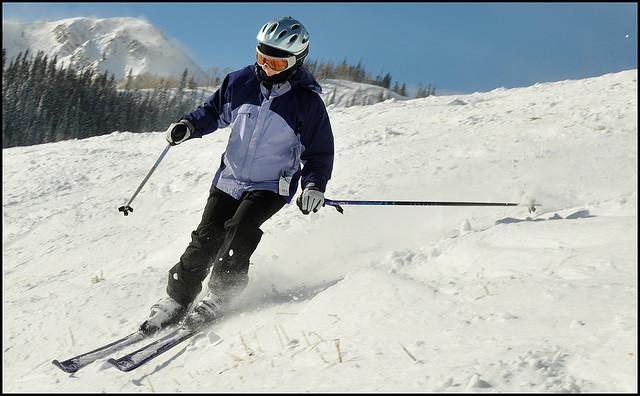What do you call the objects the person is carrying?
Concise answer only. Ski poles. Where are the goggles?
Answer briefly. On his face. Is this a new photo?
Be succinct. Yes. Is skiing fun?
Answer briefly. Yes. 